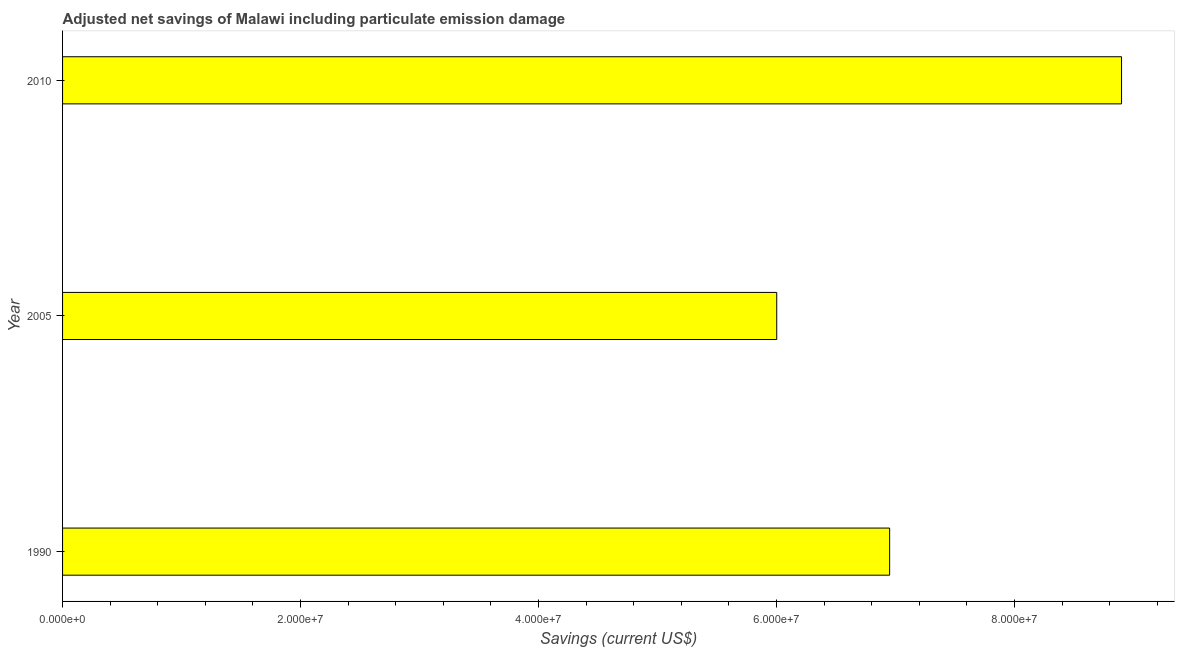What is the title of the graph?
Your answer should be compact. Adjusted net savings of Malawi including particulate emission damage. What is the label or title of the X-axis?
Provide a short and direct response. Savings (current US$). What is the label or title of the Y-axis?
Give a very brief answer. Year. What is the adjusted net savings in 2005?
Offer a terse response. 6.00e+07. Across all years, what is the maximum adjusted net savings?
Your answer should be very brief. 8.90e+07. Across all years, what is the minimum adjusted net savings?
Provide a short and direct response. 6.00e+07. In which year was the adjusted net savings maximum?
Your answer should be very brief. 2010. In which year was the adjusted net savings minimum?
Keep it short and to the point. 2005. What is the sum of the adjusted net savings?
Offer a terse response. 2.19e+08. What is the difference between the adjusted net savings in 1990 and 2005?
Make the answer very short. 9.49e+06. What is the average adjusted net savings per year?
Your answer should be very brief. 7.28e+07. What is the median adjusted net savings?
Provide a short and direct response. 6.95e+07. Do a majority of the years between 2010 and 2005 (inclusive) have adjusted net savings greater than 44000000 US$?
Your answer should be compact. No. What is the ratio of the adjusted net savings in 2005 to that in 2010?
Offer a very short reply. 0.67. Is the difference between the adjusted net savings in 1990 and 2005 greater than the difference between any two years?
Keep it short and to the point. No. What is the difference between the highest and the second highest adjusted net savings?
Ensure brevity in your answer.  1.95e+07. Is the sum of the adjusted net savings in 1990 and 2005 greater than the maximum adjusted net savings across all years?
Your answer should be compact. Yes. What is the difference between the highest and the lowest adjusted net savings?
Offer a very short reply. 2.90e+07. In how many years, is the adjusted net savings greater than the average adjusted net savings taken over all years?
Provide a succinct answer. 1. How many bars are there?
Your answer should be very brief. 3. Are all the bars in the graph horizontal?
Your response must be concise. Yes. Are the values on the major ticks of X-axis written in scientific E-notation?
Offer a very short reply. Yes. What is the Savings (current US$) of 1990?
Your response must be concise. 6.95e+07. What is the Savings (current US$) in 2005?
Provide a short and direct response. 6.00e+07. What is the Savings (current US$) of 2010?
Offer a very short reply. 8.90e+07. What is the difference between the Savings (current US$) in 1990 and 2005?
Provide a short and direct response. 9.49e+06. What is the difference between the Savings (current US$) in 1990 and 2010?
Your response must be concise. -1.95e+07. What is the difference between the Savings (current US$) in 2005 and 2010?
Give a very brief answer. -2.90e+07. What is the ratio of the Savings (current US$) in 1990 to that in 2005?
Make the answer very short. 1.16. What is the ratio of the Savings (current US$) in 1990 to that in 2010?
Your answer should be compact. 0.78. What is the ratio of the Savings (current US$) in 2005 to that in 2010?
Give a very brief answer. 0.67. 